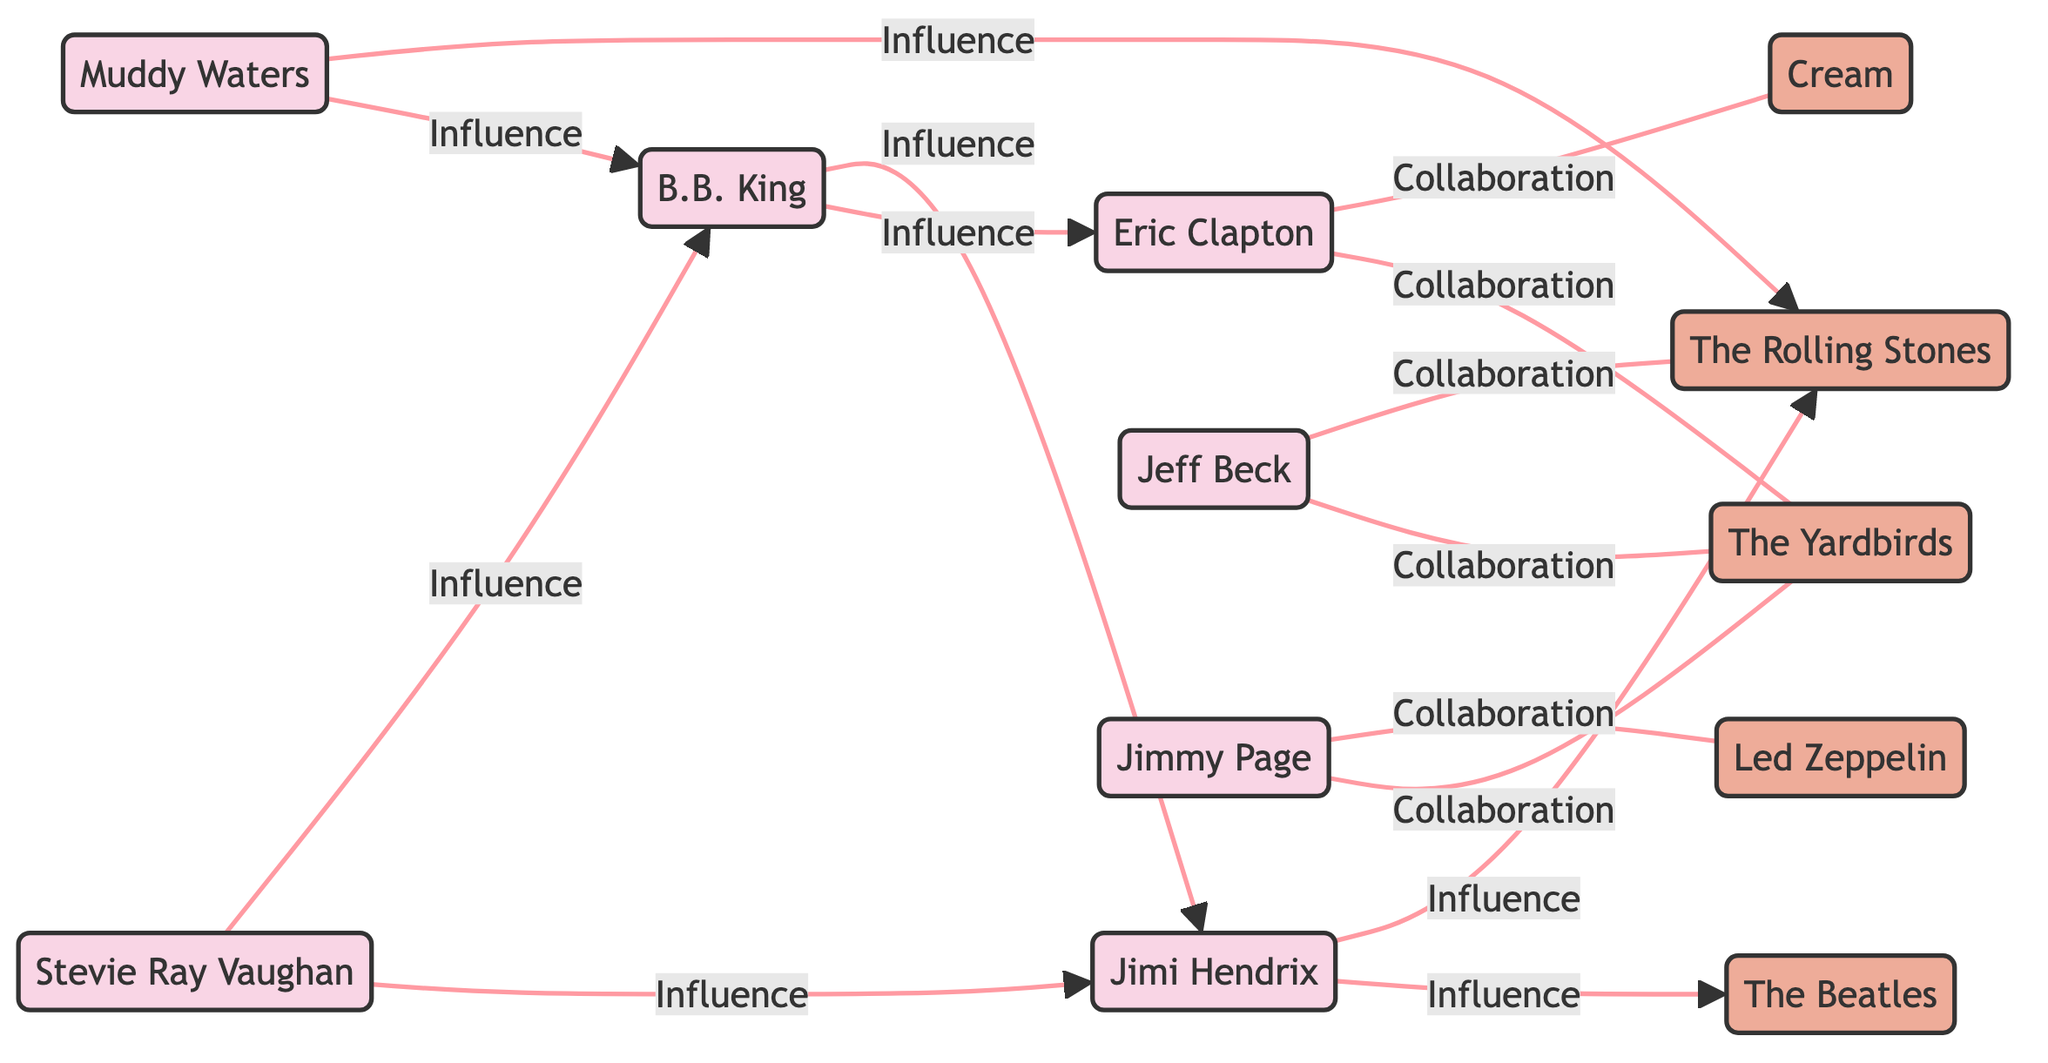What is the total number of musicians in the diagram? The nodes section lists each musician by their name, and counting these unique entries gives a total of six musicians: Jimi Hendrix, Eric Clapton, Jeff Beck, Jimmy Page, B.B. King, Muddy Waters, and Stevie Ray Vaughan.
Answer: 6 How many collaborations are shown between musicians and bands? The edges section lists specific collaborations and influence relationships. Counting the edges specifically labeled as "Collaboration," there are four edges: Eric Clapton with The Yardbirds, Eric Clapton with Cream, Jeff Beck with The Yardbirds, and Jeff Beck with The Rolling Stones, along with Jimmy Page with The Yardbirds and Jimmy Page with Led Zeppelin.
Answer: 4 Who influenced Eric Clapton? Looking through the edges that connect to Eric Clapton, the only musician that is directed towards him is B.B. King. This indicates that B.B. King is the musician who has influenced Eric Clapton in the diagram.
Answer: B.B. King Which band had members involved in collaborations with musicians from "The Yardbirds"? By examining the diagram, we see that Eric Clapton, Jeff Beck, and Jimmy Page all have collaboration connections to The Yardbirds. Therefore, the band with these collaborations is the Yardbirds itself, as all these musicians were members of that band at different times.
Answer: The Yardbirds How many musicians have influenced Jimi Hendrix? Jimi Hendrix is influenced by two musicians according to the directed edges. These musicians are B.B. King and Stevie Ray Vaughan. Therefore, the total number of musicians that influenced Jimi Hendrix in the diagram is two.
Answer: 2 What type of relationship exists between B.B. King and Muddy Waters? In the diagram, there is a directed edge from Muddy Waters to B.B. King labeled “Influence.” This indicates that the relationship type between them is influence, with Muddy Waters influencing B.B. King.
Answer: Influence How many bands are mentioned in the diagram? The nodes section lists the bands, which include The Beatles, The Yardbirds, Cream, The Rolling Stones, and Led Zeppelin. Counting these gives a total of five unique bands mentioned in the diagram.
Answer: 5 Which musician has the most influence connections directed towards them? Analyzing the edges for influence connections, B.B. King has two outgoing influence connections towards Eric Clapton and Jimi Hendrix. The musician with the most influence connections directed towards them is B.B. King.
Answer: B.B. King What is the role of Stevie Ray Vaughan in the diagram? The role of Stevie Ray Vaughan, as stated in the nodes section, is "Guitarist." He is specifically categorized as a musician and holds this role without further designations in the diagram.
Answer: Guitarist 